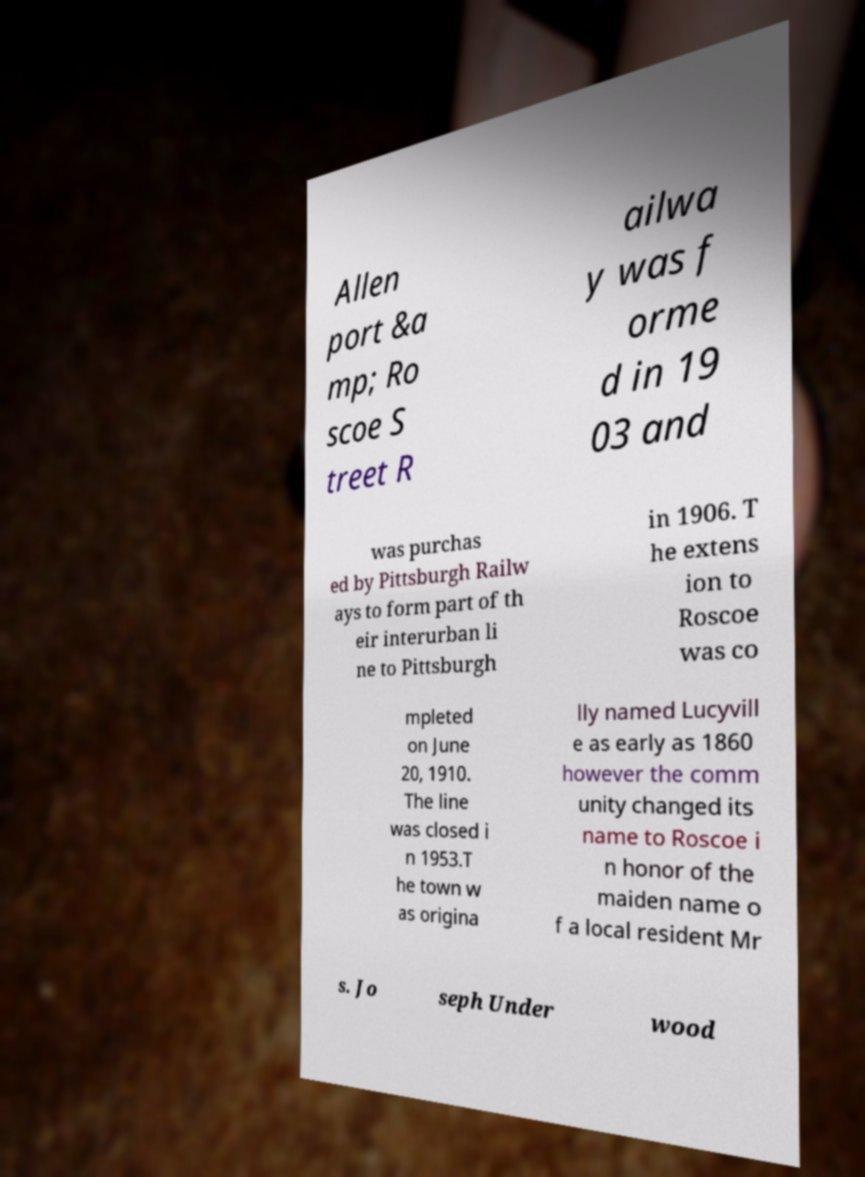For documentation purposes, I need the text within this image transcribed. Could you provide that? Allen port &a mp; Ro scoe S treet R ailwa y was f orme d in 19 03 and was purchas ed by Pittsburgh Railw ays to form part of th eir interurban li ne to Pittsburgh in 1906. T he extens ion to Roscoe was co mpleted on June 20, 1910. The line was closed i n 1953.T he town w as origina lly named Lucyvill e as early as 1860 however the comm unity changed its name to Roscoe i n honor of the maiden name o f a local resident Mr s. Jo seph Under wood 